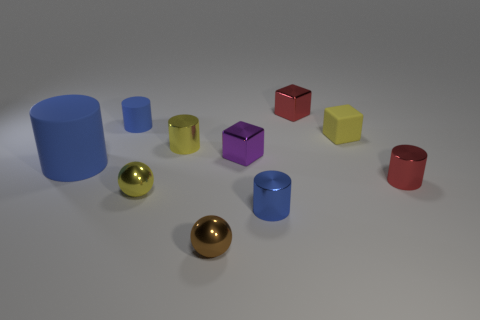Subtract all red balls. How many blue cylinders are left? 3 Subtract all small matte cylinders. How many cylinders are left? 4 Subtract 1 cylinders. How many cylinders are left? 4 Subtract all red cylinders. How many cylinders are left? 4 Subtract all cubes. How many objects are left? 7 Subtract all green cubes. Subtract all brown spheres. How many cubes are left? 3 Add 5 blue matte cylinders. How many blue matte cylinders exist? 7 Subtract 1 yellow cylinders. How many objects are left? 9 Subtract all small balls. Subtract all tiny blocks. How many objects are left? 5 Add 7 tiny brown objects. How many tiny brown objects are left? 8 